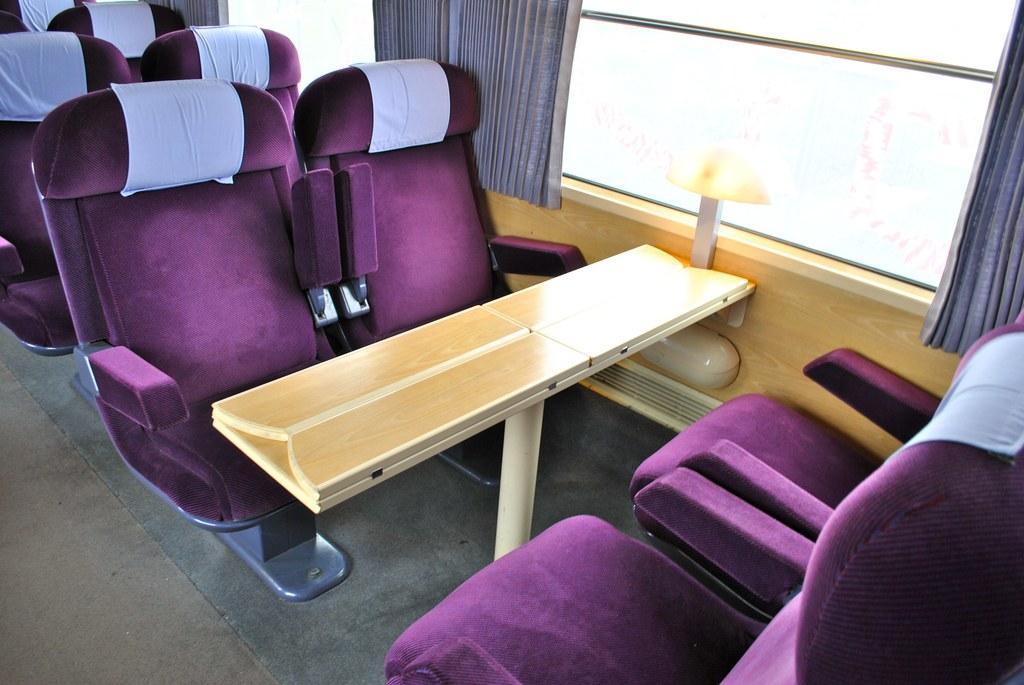Describe this image in one or two sentences. In this image there are seats, there are seats truncated towards the bottom of the image, there are seats truncated towards the left of the image, there is a table, there is window truncated towards the top of the image, there are curtains truncated towards the top of the image, there is a certain truncated towards the left of the image, there is a light, there is a wooden wall. 